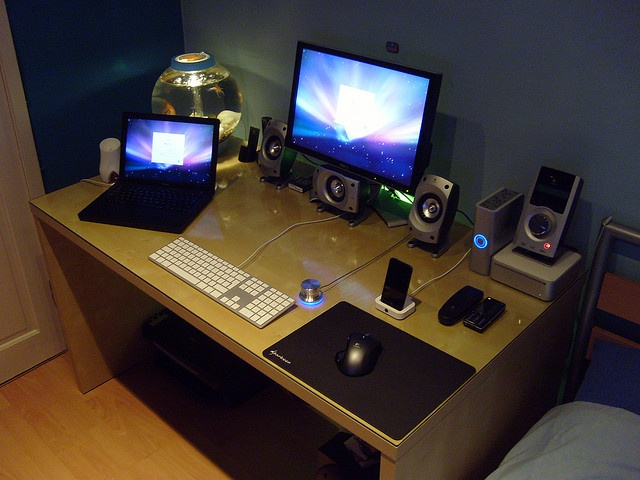Describe the objects in this image and their specific colors. I can see bed in maroon, black, gray, and navy tones, tv in maroon, white, black, lightblue, and darkblue tones, laptop in maroon, black, white, lightblue, and navy tones, keyboard in maroon, tan, and gray tones, and mouse in maroon, black, gray, olive, and tan tones in this image. 